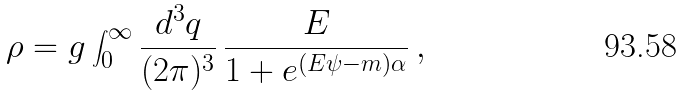<formula> <loc_0><loc_0><loc_500><loc_500>\rho = g \int ^ { \infty } _ { 0 } \frac { d ^ { 3 } q } { ( 2 \pi ) ^ { 3 } } \, \frac { E } { 1 + e ^ { ( E \psi - m ) \alpha } } \, ,</formula> 